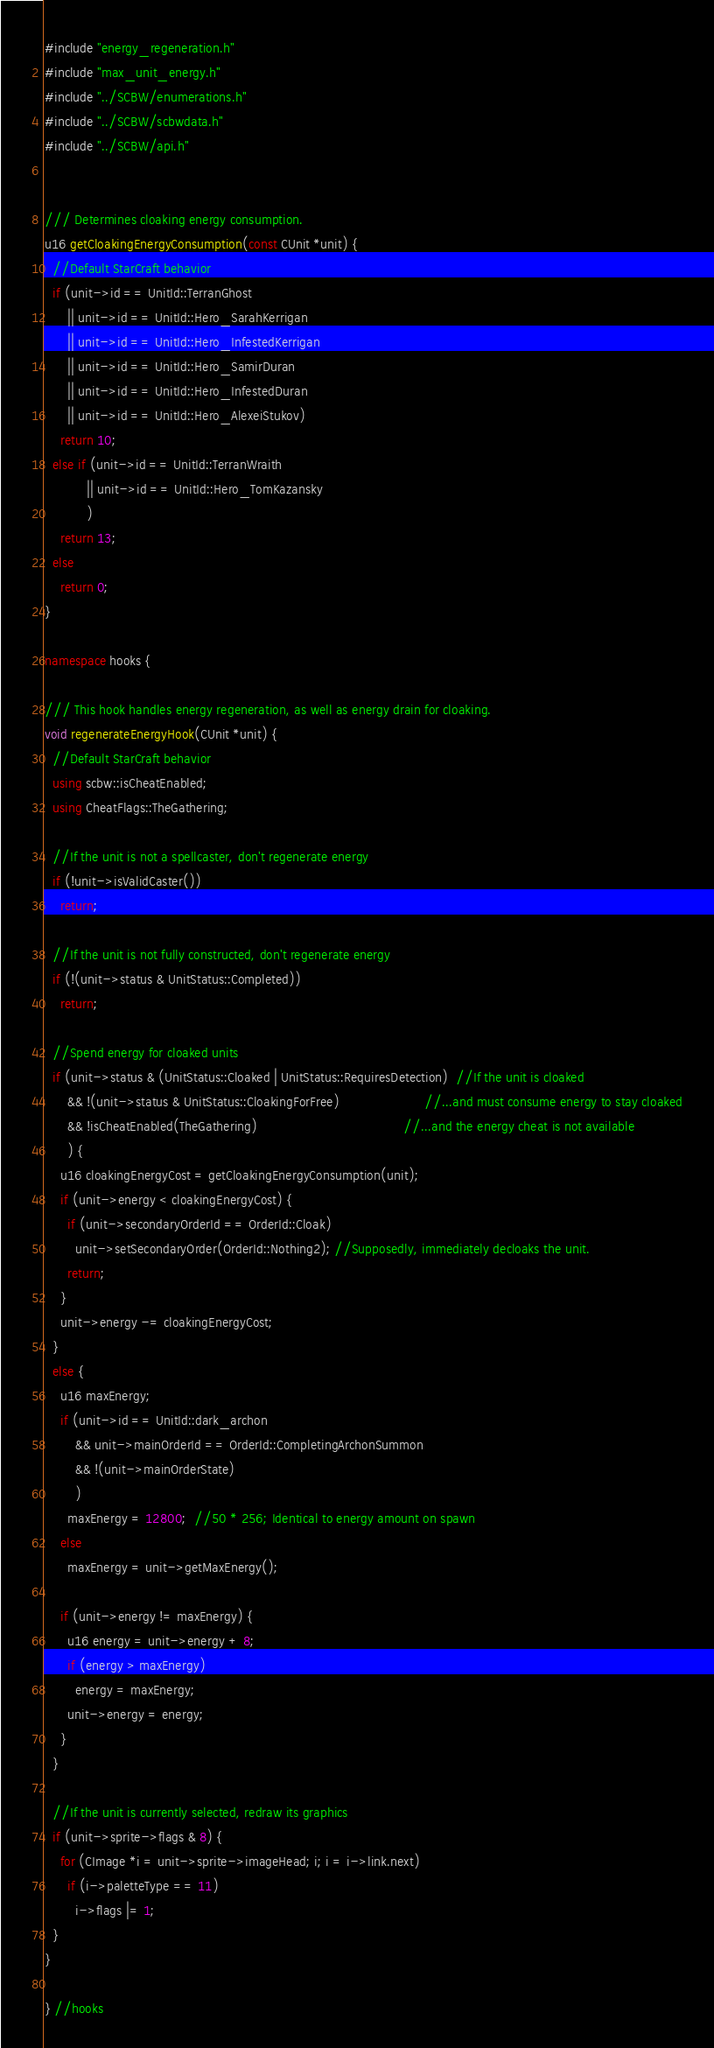<code> <loc_0><loc_0><loc_500><loc_500><_C++_>#include "energy_regeneration.h"
#include "max_unit_energy.h"
#include "../SCBW/enumerations.h"
#include "../SCBW/scbwdata.h"
#include "../SCBW/api.h"


/// Determines cloaking energy consumption.
u16 getCloakingEnergyConsumption(const CUnit *unit) {
  //Default StarCraft behavior
  if (unit->id == UnitId::TerranGhost
      || unit->id == UnitId::Hero_SarahKerrigan
      || unit->id == UnitId::Hero_InfestedKerrigan
      || unit->id == UnitId::Hero_SamirDuran
      || unit->id == UnitId::Hero_InfestedDuran
      || unit->id == UnitId::Hero_AlexeiStukov)
    return 10;
  else if (unit->id == UnitId::TerranWraith
           || unit->id == UnitId::Hero_TomKazansky
           )
    return 13;
  else
    return 0;
}

namespace hooks {

/// This hook handles energy regeneration, as well as energy drain for cloaking.
void regenerateEnergyHook(CUnit *unit) {
  //Default StarCraft behavior
  using scbw::isCheatEnabled;
  using CheatFlags::TheGathering;

  //If the unit is not a spellcaster, don't regenerate energy
  if (!unit->isValidCaster())
    return;
  
  //If the unit is not fully constructed, don't regenerate energy
  if (!(unit->status & UnitStatus::Completed))
    return;

  //Spend energy for cloaked units
  if (unit->status & (UnitStatus::Cloaked | UnitStatus::RequiresDetection)  //If the unit is cloaked
      && !(unit->status & UnitStatus::CloakingForFree)                      //...and must consume energy to stay cloaked
      && !isCheatEnabled(TheGathering)                                      //...and the energy cheat is not available
      ) {
    u16 cloakingEnergyCost = getCloakingEnergyConsumption(unit);
    if (unit->energy < cloakingEnergyCost) {
      if (unit->secondaryOrderId == OrderId::Cloak)
        unit->setSecondaryOrder(OrderId::Nothing2); //Supposedly, immediately decloaks the unit.
      return;
    }
    unit->energy -= cloakingEnergyCost;
  }
  else {
    u16 maxEnergy;
    if (unit->id == UnitId::dark_archon
        && unit->mainOrderId == OrderId::CompletingArchonSummon
        && !(unit->mainOrderState)
        )
      maxEnergy = 12800;  //50 * 256; Identical to energy amount on spawn
    else
      maxEnergy = unit->getMaxEnergy();

    if (unit->energy != maxEnergy) {
      u16 energy = unit->energy + 8;
      if (energy > maxEnergy)
        energy = maxEnergy;
      unit->energy = energy;
    }
  }

  //If the unit is currently selected, redraw its graphics
  if (unit->sprite->flags & 8) {
    for (CImage *i = unit->sprite->imageHead; i; i = i->link.next)
      if (i->paletteType == 11)
        i->flags |= 1;
  }
}

} //hooks
</code> 